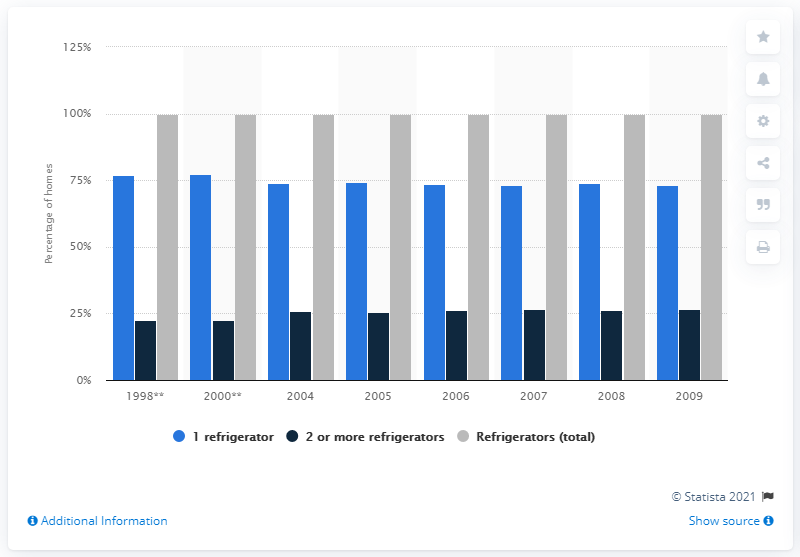Mention a couple of crucial points in this snapshot. In 1998, approximately 77.2% of Canadian households possessed one refrigerator. 